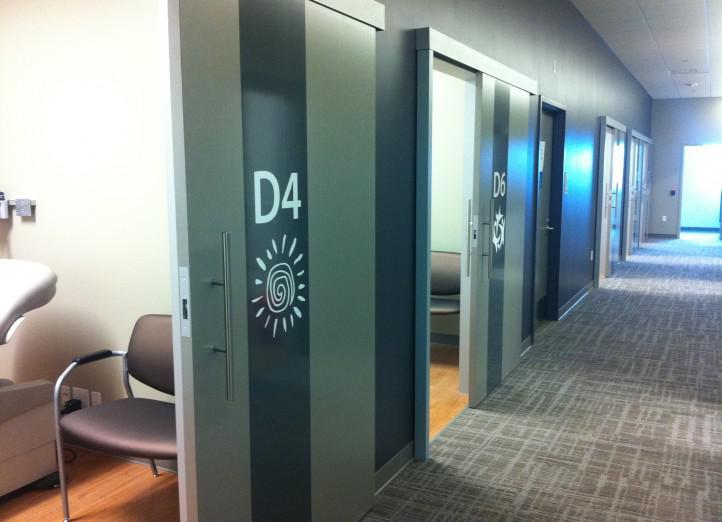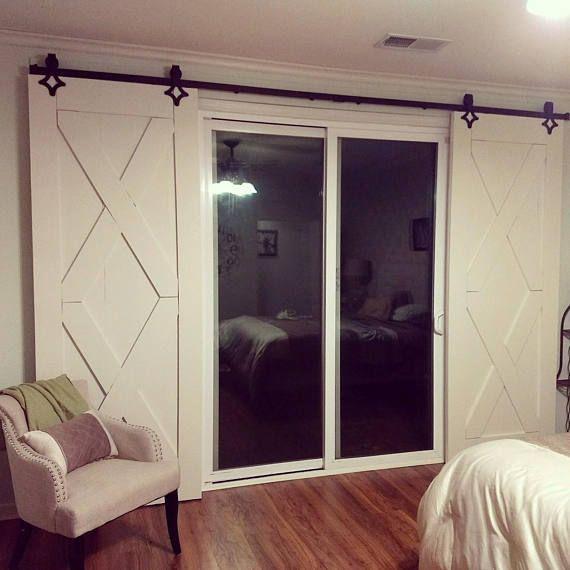The first image is the image on the left, the second image is the image on the right. Evaluate the accuracy of this statement regarding the images: "One of the images is split; the same door is being shown both open, and closed.". Is it true? Answer yes or no. No. The first image is the image on the left, the second image is the image on the right. For the images displayed, is the sentence "The left and right image contains a total of three dogs with two identical one on top of each other." factually correct? Answer yes or no. No. 